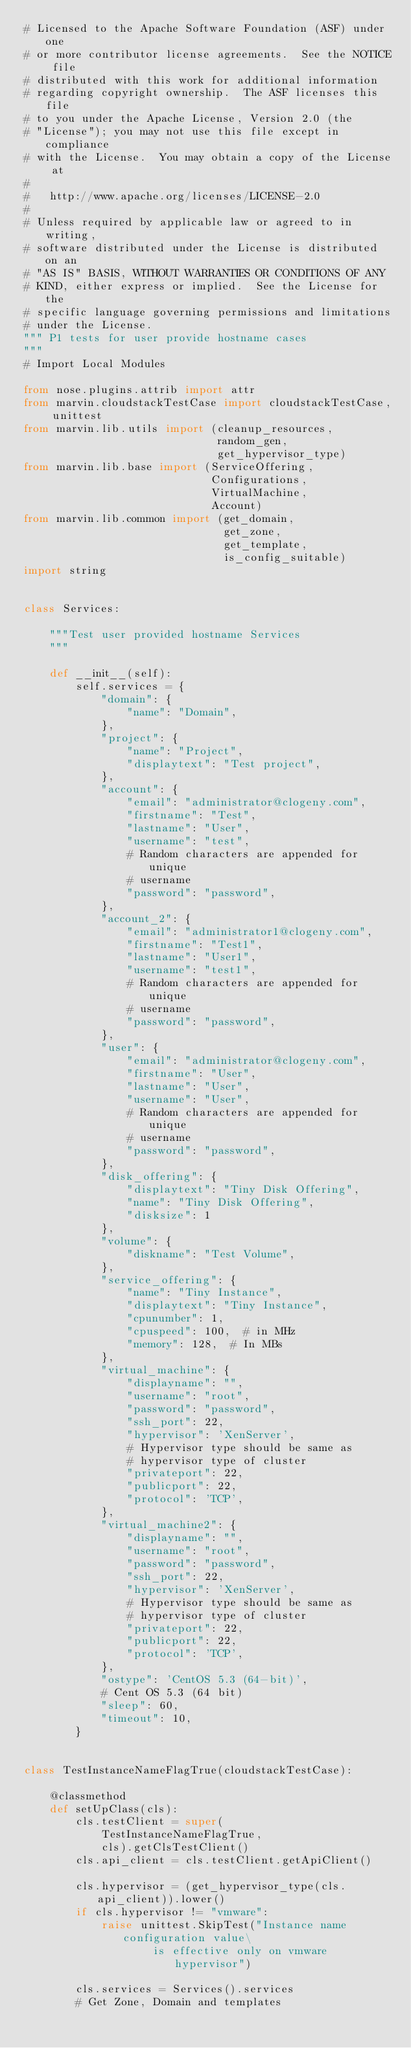<code> <loc_0><loc_0><loc_500><loc_500><_Python_># Licensed to the Apache Software Foundation (ASF) under one
# or more contributor license agreements.  See the NOTICE file
# distributed with this work for additional information
# regarding copyright ownership.  The ASF licenses this file
# to you under the Apache License, Version 2.0 (the
# "License"); you may not use this file except in compliance
# with the License.  You may obtain a copy of the License at
#
#   http://www.apache.org/licenses/LICENSE-2.0
#
# Unless required by applicable law or agreed to in writing,
# software distributed under the License is distributed on an
# "AS IS" BASIS, WITHOUT WARRANTIES OR CONDITIONS OF ANY
# KIND, either express or implied.  See the License for the
# specific language governing permissions and limitations
# under the License.
""" P1 tests for user provide hostname cases
"""
# Import Local Modules

from nose.plugins.attrib import attr
from marvin.cloudstackTestCase import cloudstackTestCase, unittest
from marvin.lib.utils import (cleanup_resources,
                              random_gen,
                              get_hypervisor_type)
from marvin.lib.base import (ServiceOffering,
                             Configurations,
                             VirtualMachine,
                             Account)
from marvin.lib.common import (get_domain,
                               get_zone,
                               get_template,
                               is_config_suitable)
import string


class Services:

    """Test user provided hostname Services
    """

    def __init__(self):
        self.services = {
            "domain": {
                "name": "Domain",
            },
            "project": {
                "name": "Project",
                "displaytext": "Test project",
            },
            "account": {
                "email": "administrator@clogeny.com",
                "firstname": "Test",
                "lastname": "User",
                "username": "test",
                # Random characters are appended for unique
                # username
                "password": "password",
            },
            "account_2": {
                "email": "administrator1@clogeny.com",
                "firstname": "Test1",
                "lastname": "User1",
                "username": "test1",
                # Random characters are appended for unique
                # username
                "password": "password",
            },
            "user": {
                "email": "administrator@clogeny.com",
                "firstname": "User",
                "lastname": "User",
                "username": "User",
                # Random characters are appended for unique
                # username
                "password": "password",
            },
            "disk_offering": {
                "displaytext": "Tiny Disk Offering",
                "name": "Tiny Disk Offering",
                "disksize": 1
            },
            "volume": {
                "diskname": "Test Volume",
            },
            "service_offering": {
                "name": "Tiny Instance",
                "displaytext": "Tiny Instance",
                "cpunumber": 1,
                "cpuspeed": 100,  # in MHz
                "memory": 128,  # In MBs
            },
            "virtual_machine": {
                "displayname": "",
                "username": "root",
                "password": "password",
                "ssh_port": 22,
                "hypervisor": 'XenServer',
                # Hypervisor type should be same as
                # hypervisor type of cluster
                "privateport": 22,
                "publicport": 22,
                "protocol": 'TCP',
            },
            "virtual_machine2": {
                "displayname": "",
                "username": "root",
                "password": "password",
                "ssh_port": 22,
                "hypervisor": 'XenServer',
                # Hypervisor type should be same as
                # hypervisor type of cluster
                "privateport": 22,
                "publicport": 22,
                "protocol": 'TCP',
            },
            "ostype": 'CentOS 5.3 (64-bit)',
            # Cent OS 5.3 (64 bit)
            "sleep": 60,
            "timeout": 10,
        }


class TestInstanceNameFlagTrue(cloudstackTestCase):

    @classmethod
    def setUpClass(cls):
        cls.testClient = super(
            TestInstanceNameFlagTrue,
            cls).getClsTestClient()
        cls.api_client = cls.testClient.getApiClient()

        cls.hypervisor = (get_hypervisor_type(cls.api_client)).lower()
        if cls.hypervisor != "vmware":
            raise unittest.SkipTest("Instance name configuration value\
                    is effective only on vmware hypervisor")

        cls.services = Services().services
        # Get Zone, Domain and templates</code> 